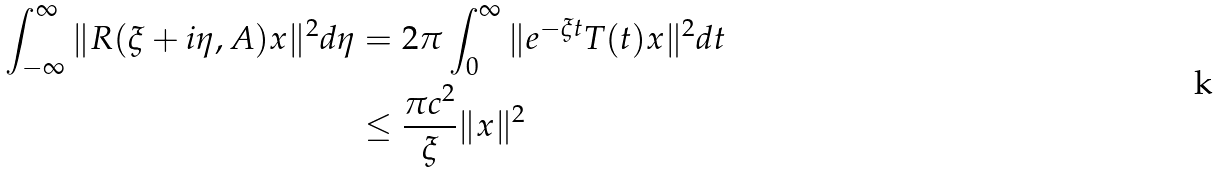Convert formula to latex. <formula><loc_0><loc_0><loc_500><loc_500>\int _ { - \infty } ^ { \infty } \| R ( \xi + i \eta , A ) x \| ^ { 2 } d \eta & = 2 \pi \int _ { 0 } ^ { \infty } \| e ^ { - \xi t } T ( t ) x \| ^ { 2 } d t \\ & \leq \frac { \pi c ^ { 2 } } { \xi } \| x \| ^ { 2 }</formula> 